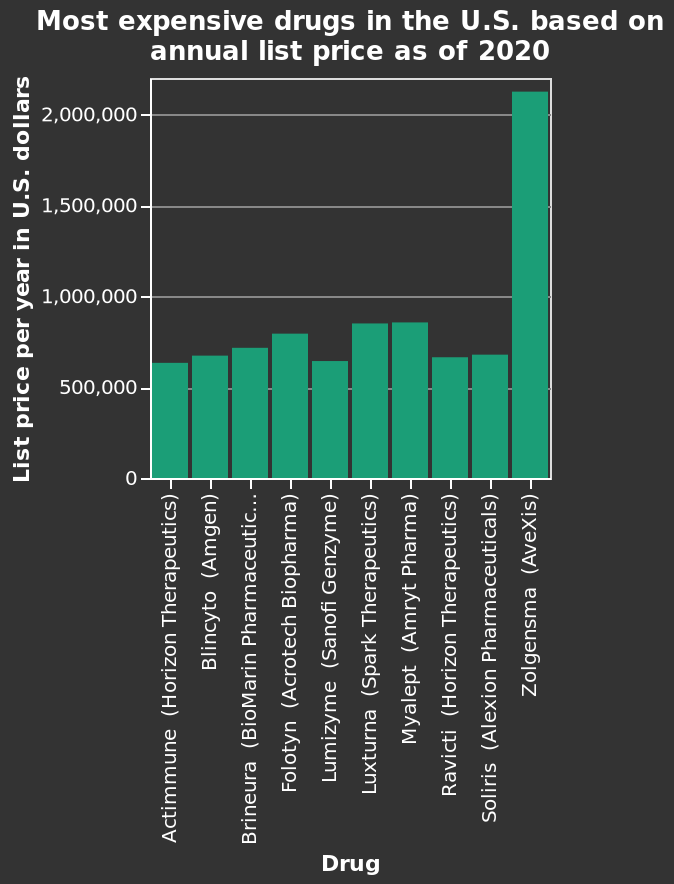<image>
Describe the following image in detail Here a bar graph is called Most expensive drugs in the U.S. based on annual list price as of 2020. The x-axis plots Drug. There is a linear scale from 0 to 2,000,000 on the y-axis, marked List price per year in U.S. dollars. What is the title or name of the bar graph?  The bar graph is called "Most expensive drugs in the U.S. based on annual list price as of 2020." What is the price range of all the drugs mentioned, except Zolgensma (AveXis)?  The price range of all the drugs mentioned, except Zolgensma (AveXis), is between 500,000 and 1,000,000 U.S Dollars per year. 